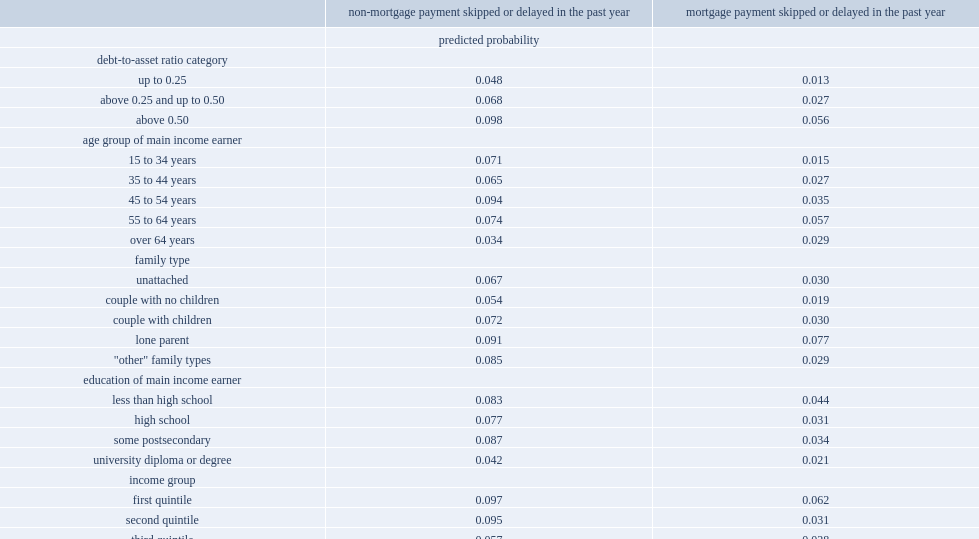By what percentage would families with a debt-to-asset ratio up to 0.25 skip or delay a non-mortgage payment? 0.048. By what percentage would families with a debt-to-asset ratio above o.5 skip or delay a non-mortgage payment? 0.098. 